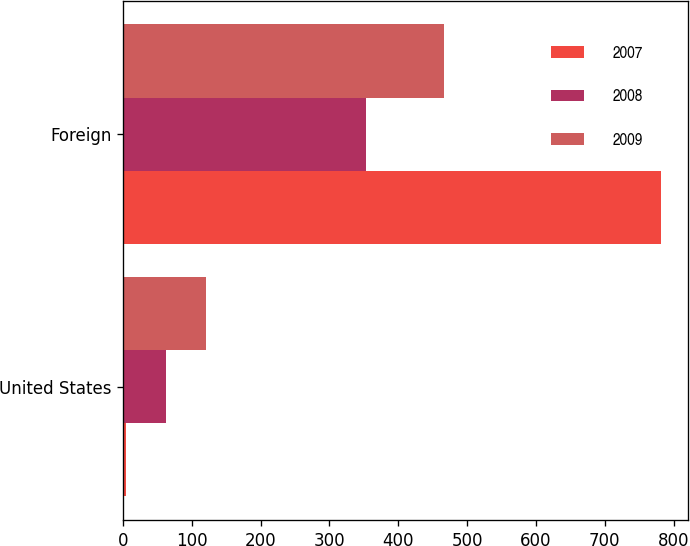Convert chart to OTSL. <chart><loc_0><loc_0><loc_500><loc_500><stacked_bar_chart><ecel><fcel>United States<fcel>Foreign<nl><fcel>2007<fcel>5<fcel>782<nl><fcel>2008<fcel>62<fcel>353<nl><fcel>2009<fcel>121<fcel>467<nl></chart> 